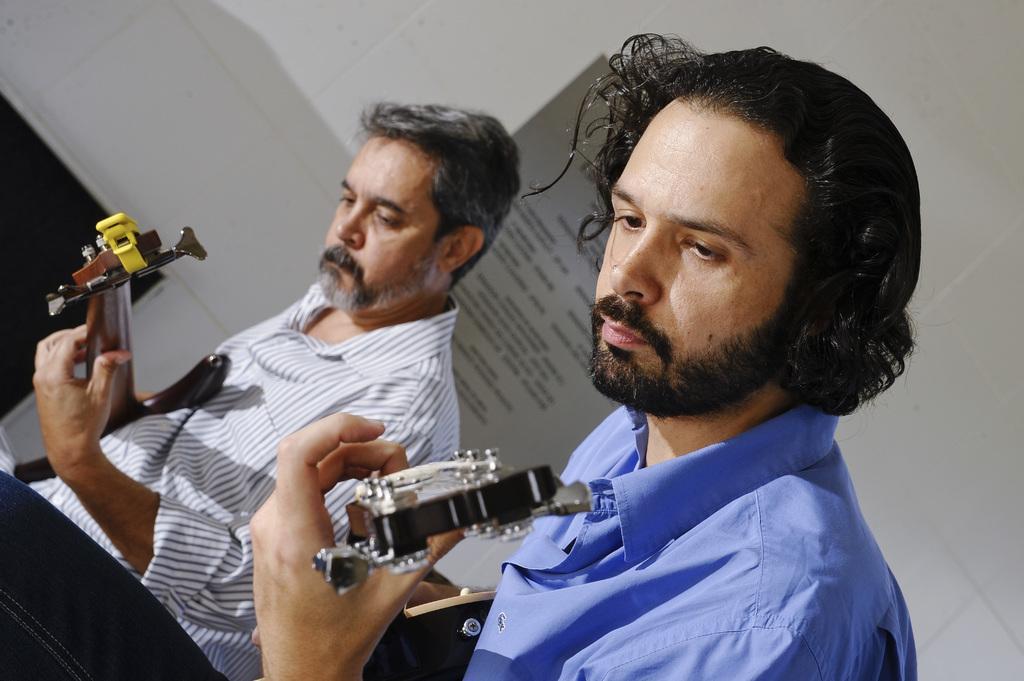Could you give a brief overview of what you see in this image? This picture is clicked inside a room. There are two musicians in the room and are playing guitar. The man to the right corner is wearing blue shirt and has long hair. Behind them there is wall and a board. 